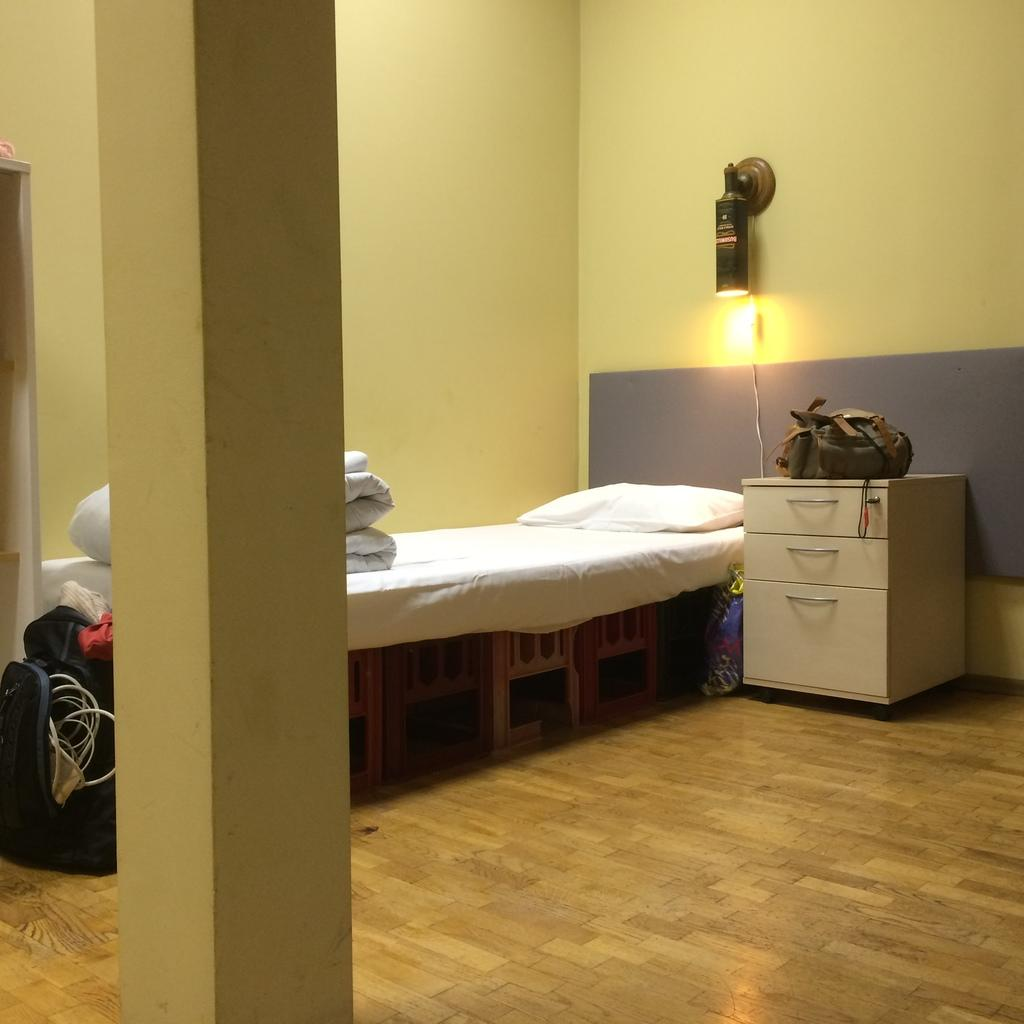What type of space is shown in the image? The image depicts a room. What furniture is present in the room? There is a bed in the room. What is covering the bed? The bed has a bed sheet. What are the pillows used for on the bed? The bed has pillows. Where is the bag located in the room? The bag is located on the left side of the room. What type of fruit is hanging from the ceiling in the image? There is no fruit hanging from the ceiling in the image. How many quinces are present in the room? There is no mention of quinces in the image. 